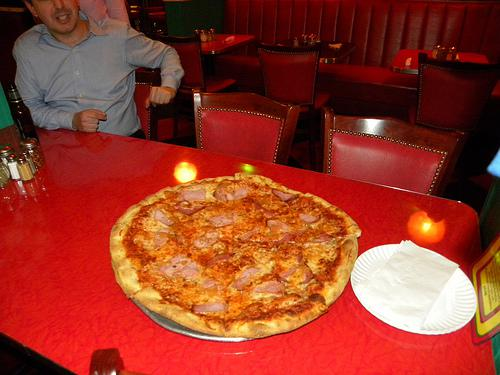Question: what type of food is this?
Choices:
A. Rice.
B. Beans.
C. Pizza.
D. Green beans.
Answer with the letter. Answer: C Question: who is the person seen partially in the photo probably?
Choices:
A. Boy.
B. Man.
C. Uncle.
D. Brother.
Answer with the letter. Answer: B Question: where does this photo appear to have been taken?
Choices:
A. On a lake.
B. In a park.
C. A football field.
D. Restaurant.
Answer with the letter. Answer: D 